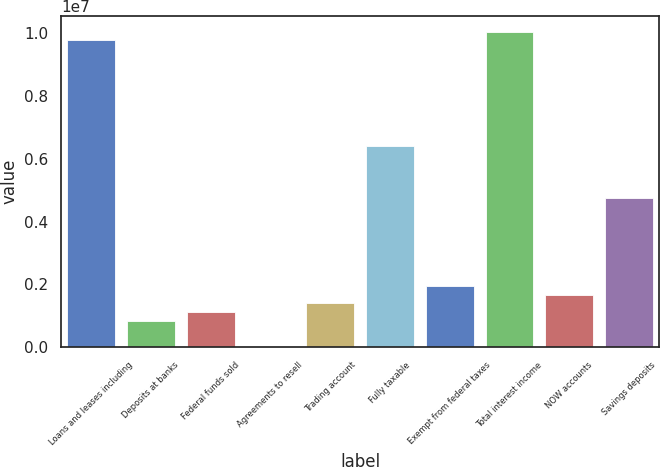Convert chart to OTSL. <chart><loc_0><loc_0><loc_500><loc_500><bar_chart><fcel>Loans and leases including<fcel>Deposits at banks<fcel>Federal funds sold<fcel>Agreements to resell<fcel>Trading account<fcel>Fully taxable<fcel>Exempt from federal taxes<fcel>Total interest income<fcel>NOW accounts<fcel>Savings deposits<nl><fcel>9.76043e+06<fcel>836609<fcel>1.11548e+06<fcel>1<fcel>1.39435e+06<fcel>6.41399e+06<fcel>1.95209e+06<fcel>1.00393e+07<fcel>1.67322e+06<fcel>4.74078e+06<nl></chart> 